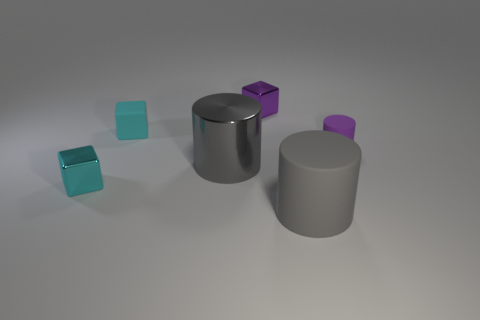Add 3 tiny purple shiny cubes. How many objects exist? 9 Subtract 1 cyan blocks. How many objects are left? 5 Subtract all big red matte cubes. Subtract all large gray cylinders. How many objects are left? 4 Add 4 purple metal things. How many purple metal things are left? 5 Add 6 small green metal cylinders. How many small green metal cylinders exist? 6 